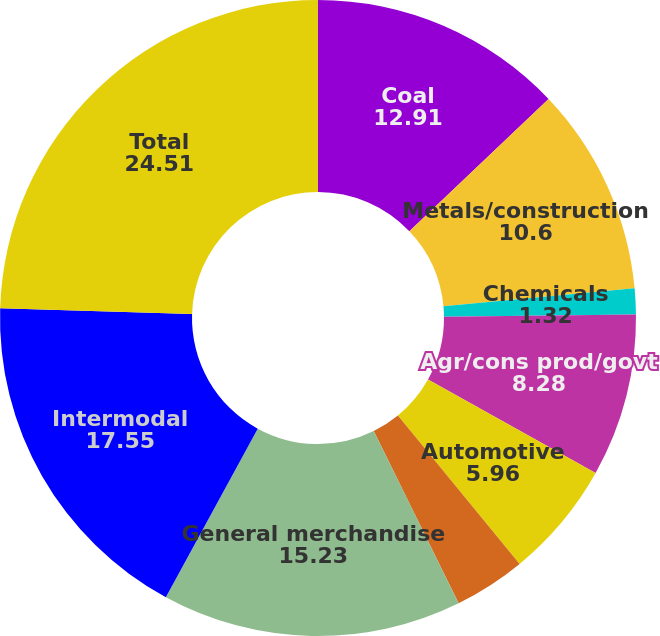Convert chart to OTSL. <chart><loc_0><loc_0><loc_500><loc_500><pie_chart><fcel>Coal<fcel>Metals/construction<fcel>Chemicals<fcel>Agr/cons prod/govt<fcel>Automotive<fcel>Paper/clay/forest<fcel>General merchandise<fcel>Intermodal<fcel>Total<nl><fcel>12.91%<fcel>10.6%<fcel>1.32%<fcel>8.28%<fcel>5.96%<fcel>3.64%<fcel>15.23%<fcel>17.55%<fcel>24.51%<nl></chart> 